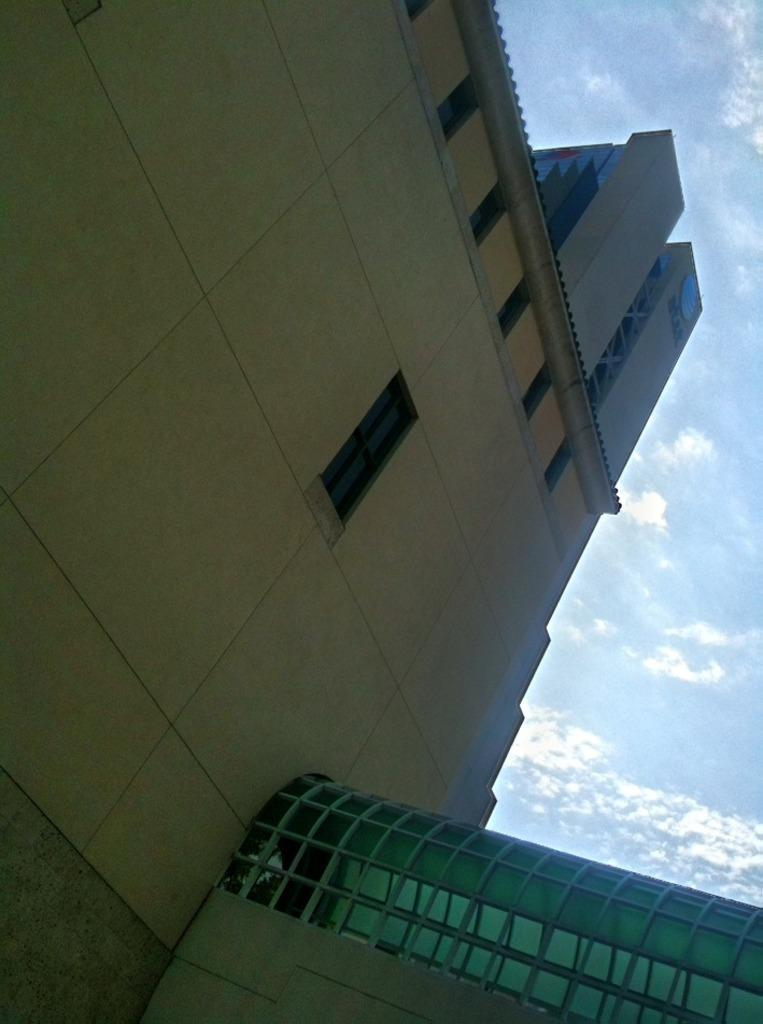What structure is the main subject of the image? There is a building in the image. What feature can be seen on the building? The building has windows on the top. What is visible in the background of the image? The sky is visible in the image. What can be observed in the sky? Clouds are present in the sky. What type of jam is being spread on the wire in the image? There is no jam or wire present in the image; it features a building with windows and a sky with clouds. 